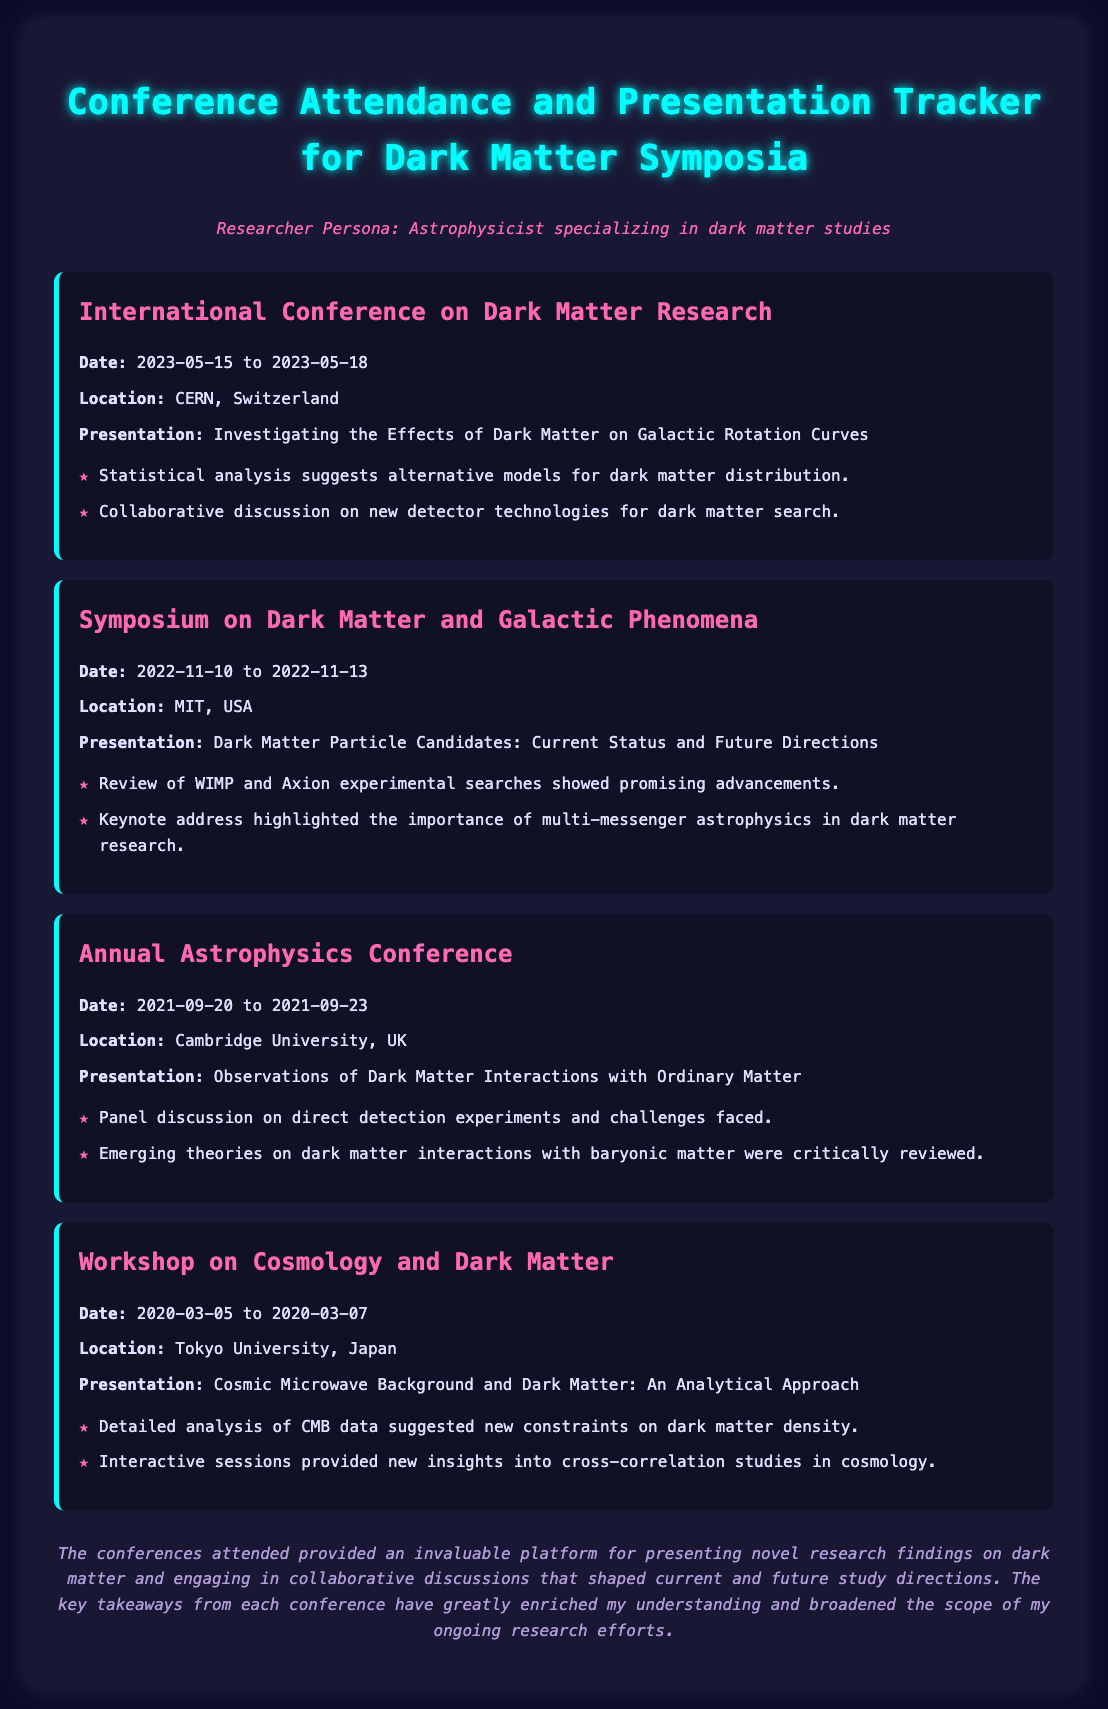what is the location of the latest conference attended? The most recent conference mentioned is the International Conference on Dark Matter Research, held at CERN, Switzerland.
Answer: CERN, Switzerland what are the dates of the Symposium on Dark Matter and Galactic Phenomena? This symposium took place from November 10 to November 13 in 2022.
Answer: 2022-11-10 to 2022-11-13 which presentation discussed dark matter particle candidates? The presentation titled "Dark Matter Particle Candidates: Current Status and Future Directions" is about dark matter particle candidates.
Answer: Dark Matter Particle Candidates: Current Status and Future Directions how many conferences were attended in total? The document lists four conferences that were attended.
Answer: 4 what was a key takeaway from the Workshop on Cosmology and Dark Matter? A key takeaway was that detailed analysis of CMB data suggested new constraints on dark matter density.
Answer: New constraints on dark matter density which conference had discussions on new detector technologies? The International Conference on Dark Matter Research included collaborative discussions on new detector technologies.
Answer: International Conference on Dark Matter Research what does the comments section highlight about the conferences? The comments section emphasizes the invaluable platform for presenting research findings and engaging in collaborative discussions.
Answer: Invaluable platform for presenting research findings who gave the keynote address at the Symposium on Dark Matter and Galactic Phenomena? The document does not specify the name of the person who gave the keynote address.
Answer: Not specified 